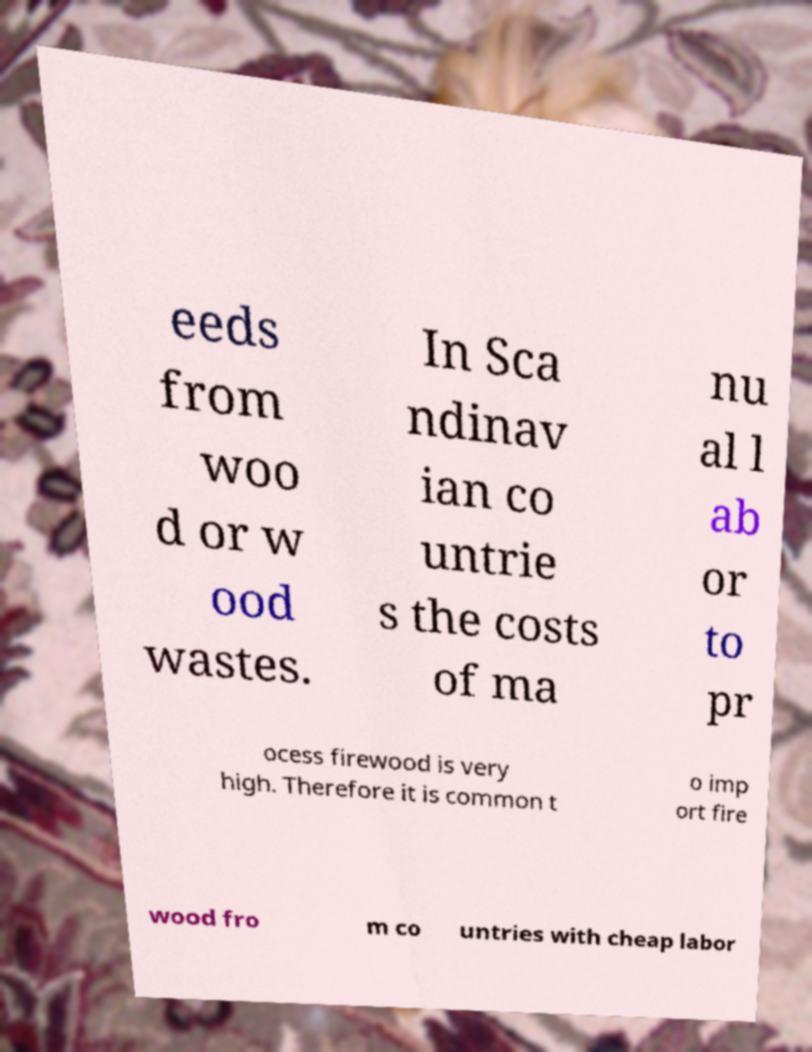What messages or text are displayed in this image? I need them in a readable, typed format. eeds from woo d or w ood wastes. In Sca ndinav ian co untrie s the costs of ma nu al l ab or to pr ocess firewood is very high. Therefore it is common t o imp ort fire wood fro m co untries with cheap labor 